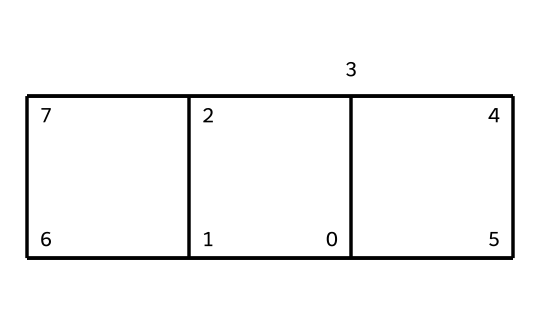What is the molecular formula of cubane? To determine the molecular formula, count the number of carbon (C) and hydrogen (H) atoms in the structure. Cubane has 8 carbon atoms and 8 hydrogen atoms. Thus, the molecular formula is C8H8.
Answer: C8H8 How many total rings are present in cubane? The structure of cubane consists of a single cubic ring system. Each corner of the cube represents a carbon atom with additional carbon atoms making four interconnecting rings. Therefore, there are three equivalent rings forming the cubic structure.
Answer: 3 What is the degree of unsaturation in cubane? The degree of unsaturation formula can be calculated using the formula: (2C + 2 + N - H - X) / 2. For cubane (C8H8), substituting gives (2(8) + 2 - 8) / 2 = 6 / 2 = 3. Therefore, cubane has a degree of unsaturation of 3.
Answer: 3 Is cubane a saturated or unsaturated hydrocarbon? Since cubane has a degree of unsaturation greater than 0, it contains double or triple bonds or rings. However, cubane, specifically having only single bonds and a closed cubic structure is classified as a saturated hydrocarbon.
Answer: saturated Can cubane potentially serve as a high-energy fuel? The structure of cubane, characterized by its compact and strained geometry, allows it to store energy efficiently. The high energy density of cubane makes it suitable for applications in high-energy fuels.
Answer: yes What type of chemical compound is cubane? Cubane is classified as a cage compound due to its unique three-dimensional cubic structure that encases the carbon atoms in a closed geometric form. This distinguishes it from other types of hydrocarbons.
Answer: cage compound 